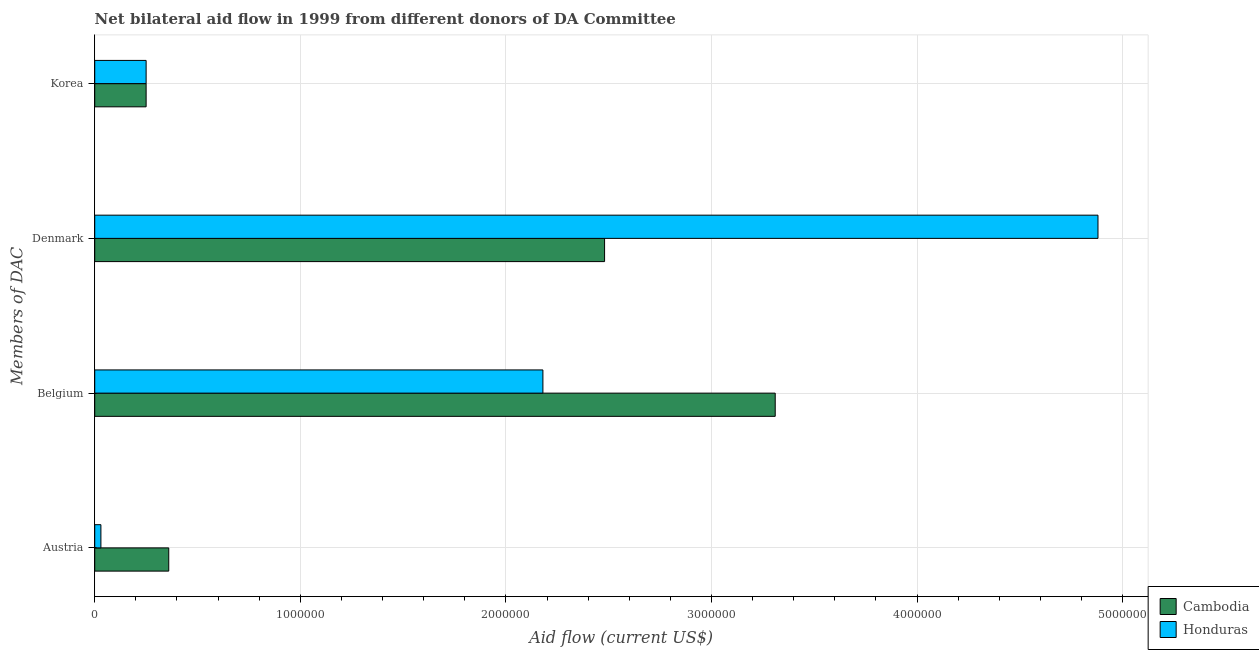Are the number of bars per tick equal to the number of legend labels?
Provide a short and direct response. Yes. Are the number of bars on each tick of the Y-axis equal?
Give a very brief answer. Yes. How many bars are there on the 4th tick from the top?
Make the answer very short. 2. How many bars are there on the 2nd tick from the bottom?
Your response must be concise. 2. What is the amount of aid given by austria in Cambodia?
Your answer should be compact. 3.60e+05. Across all countries, what is the maximum amount of aid given by belgium?
Give a very brief answer. 3.31e+06. Across all countries, what is the minimum amount of aid given by denmark?
Your response must be concise. 2.48e+06. In which country was the amount of aid given by belgium maximum?
Provide a succinct answer. Cambodia. In which country was the amount of aid given by korea minimum?
Make the answer very short. Cambodia. What is the total amount of aid given by belgium in the graph?
Your response must be concise. 5.49e+06. What is the difference between the amount of aid given by belgium in Honduras and the amount of aid given by denmark in Cambodia?
Your answer should be compact. -3.00e+05. What is the average amount of aid given by belgium per country?
Keep it short and to the point. 2.74e+06. What is the difference between the amount of aid given by korea and amount of aid given by belgium in Honduras?
Ensure brevity in your answer.  -1.93e+06. Is the difference between the amount of aid given by denmark in Honduras and Cambodia greater than the difference between the amount of aid given by korea in Honduras and Cambodia?
Ensure brevity in your answer.  Yes. What is the difference between the highest and the second highest amount of aid given by denmark?
Offer a very short reply. 2.40e+06. What is the difference between the highest and the lowest amount of aid given by austria?
Your answer should be very brief. 3.30e+05. In how many countries, is the amount of aid given by korea greater than the average amount of aid given by korea taken over all countries?
Make the answer very short. 0. Is it the case that in every country, the sum of the amount of aid given by korea and amount of aid given by belgium is greater than the sum of amount of aid given by denmark and amount of aid given by austria?
Your response must be concise. Yes. What does the 2nd bar from the top in Belgium represents?
Give a very brief answer. Cambodia. What does the 2nd bar from the bottom in Denmark represents?
Offer a very short reply. Honduras. Is it the case that in every country, the sum of the amount of aid given by austria and amount of aid given by belgium is greater than the amount of aid given by denmark?
Your answer should be very brief. No. Are all the bars in the graph horizontal?
Give a very brief answer. Yes. Are the values on the major ticks of X-axis written in scientific E-notation?
Your answer should be very brief. No. Does the graph contain any zero values?
Make the answer very short. No. Where does the legend appear in the graph?
Your answer should be compact. Bottom right. What is the title of the graph?
Your answer should be compact. Net bilateral aid flow in 1999 from different donors of DA Committee. What is the label or title of the X-axis?
Your answer should be very brief. Aid flow (current US$). What is the label or title of the Y-axis?
Your response must be concise. Members of DAC. What is the Aid flow (current US$) of Cambodia in Austria?
Ensure brevity in your answer.  3.60e+05. What is the Aid flow (current US$) in Cambodia in Belgium?
Keep it short and to the point. 3.31e+06. What is the Aid flow (current US$) in Honduras in Belgium?
Make the answer very short. 2.18e+06. What is the Aid flow (current US$) in Cambodia in Denmark?
Your response must be concise. 2.48e+06. What is the Aid flow (current US$) in Honduras in Denmark?
Offer a very short reply. 4.88e+06. What is the Aid flow (current US$) in Cambodia in Korea?
Provide a short and direct response. 2.50e+05. Across all Members of DAC, what is the maximum Aid flow (current US$) of Cambodia?
Provide a short and direct response. 3.31e+06. Across all Members of DAC, what is the maximum Aid flow (current US$) of Honduras?
Provide a succinct answer. 4.88e+06. Across all Members of DAC, what is the minimum Aid flow (current US$) of Honduras?
Keep it short and to the point. 3.00e+04. What is the total Aid flow (current US$) in Cambodia in the graph?
Provide a succinct answer. 6.40e+06. What is the total Aid flow (current US$) in Honduras in the graph?
Offer a very short reply. 7.34e+06. What is the difference between the Aid flow (current US$) in Cambodia in Austria and that in Belgium?
Your answer should be compact. -2.95e+06. What is the difference between the Aid flow (current US$) of Honduras in Austria and that in Belgium?
Provide a succinct answer. -2.15e+06. What is the difference between the Aid flow (current US$) of Cambodia in Austria and that in Denmark?
Offer a very short reply. -2.12e+06. What is the difference between the Aid flow (current US$) in Honduras in Austria and that in Denmark?
Your answer should be very brief. -4.85e+06. What is the difference between the Aid flow (current US$) of Cambodia in Austria and that in Korea?
Provide a succinct answer. 1.10e+05. What is the difference between the Aid flow (current US$) of Cambodia in Belgium and that in Denmark?
Provide a succinct answer. 8.30e+05. What is the difference between the Aid flow (current US$) of Honduras in Belgium and that in Denmark?
Give a very brief answer. -2.70e+06. What is the difference between the Aid flow (current US$) of Cambodia in Belgium and that in Korea?
Provide a short and direct response. 3.06e+06. What is the difference between the Aid flow (current US$) of Honduras in Belgium and that in Korea?
Keep it short and to the point. 1.93e+06. What is the difference between the Aid flow (current US$) in Cambodia in Denmark and that in Korea?
Provide a succinct answer. 2.23e+06. What is the difference between the Aid flow (current US$) of Honduras in Denmark and that in Korea?
Offer a very short reply. 4.63e+06. What is the difference between the Aid flow (current US$) in Cambodia in Austria and the Aid flow (current US$) in Honduras in Belgium?
Your answer should be compact. -1.82e+06. What is the difference between the Aid flow (current US$) in Cambodia in Austria and the Aid flow (current US$) in Honduras in Denmark?
Offer a terse response. -4.52e+06. What is the difference between the Aid flow (current US$) of Cambodia in Belgium and the Aid flow (current US$) of Honduras in Denmark?
Give a very brief answer. -1.57e+06. What is the difference between the Aid flow (current US$) in Cambodia in Belgium and the Aid flow (current US$) in Honduras in Korea?
Give a very brief answer. 3.06e+06. What is the difference between the Aid flow (current US$) of Cambodia in Denmark and the Aid flow (current US$) of Honduras in Korea?
Make the answer very short. 2.23e+06. What is the average Aid flow (current US$) of Cambodia per Members of DAC?
Provide a short and direct response. 1.60e+06. What is the average Aid flow (current US$) in Honduras per Members of DAC?
Your response must be concise. 1.84e+06. What is the difference between the Aid flow (current US$) in Cambodia and Aid flow (current US$) in Honduras in Belgium?
Keep it short and to the point. 1.13e+06. What is the difference between the Aid flow (current US$) of Cambodia and Aid flow (current US$) of Honduras in Denmark?
Offer a terse response. -2.40e+06. What is the difference between the Aid flow (current US$) in Cambodia and Aid flow (current US$) in Honduras in Korea?
Your answer should be very brief. 0. What is the ratio of the Aid flow (current US$) in Cambodia in Austria to that in Belgium?
Your response must be concise. 0.11. What is the ratio of the Aid flow (current US$) of Honduras in Austria to that in Belgium?
Ensure brevity in your answer.  0.01. What is the ratio of the Aid flow (current US$) in Cambodia in Austria to that in Denmark?
Offer a very short reply. 0.15. What is the ratio of the Aid flow (current US$) of Honduras in Austria to that in Denmark?
Provide a succinct answer. 0.01. What is the ratio of the Aid flow (current US$) in Cambodia in Austria to that in Korea?
Your answer should be very brief. 1.44. What is the ratio of the Aid flow (current US$) of Honduras in Austria to that in Korea?
Make the answer very short. 0.12. What is the ratio of the Aid flow (current US$) of Cambodia in Belgium to that in Denmark?
Your response must be concise. 1.33. What is the ratio of the Aid flow (current US$) of Honduras in Belgium to that in Denmark?
Your response must be concise. 0.45. What is the ratio of the Aid flow (current US$) of Cambodia in Belgium to that in Korea?
Make the answer very short. 13.24. What is the ratio of the Aid flow (current US$) in Honduras in Belgium to that in Korea?
Offer a very short reply. 8.72. What is the ratio of the Aid flow (current US$) in Cambodia in Denmark to that in Korea?
Your answer should be very brief. 9.92. What is the ratio of the Aid flow (current US$) in Honduras in Denmark to that in Korea?
Your answer should be very brief. 19.52. What is the difference between the highest and the second highest Aid flow (current US$) of Cambodia?
Give a very brief answer. 8.30e+05. What is the difference between the highest and the second highest Aid flow (current US$) in Honduras?
Offer a very short reply. 2.70e+06. What is the difference between the highest and the lowest Aid flow (current US$) in Cambodia?
Provide a succinct answer. 3.06e+06. What is the difference between the highest and the lowest Aid flow (current US$) in Honduras?
Offer a terse response. 4.85e+06. 